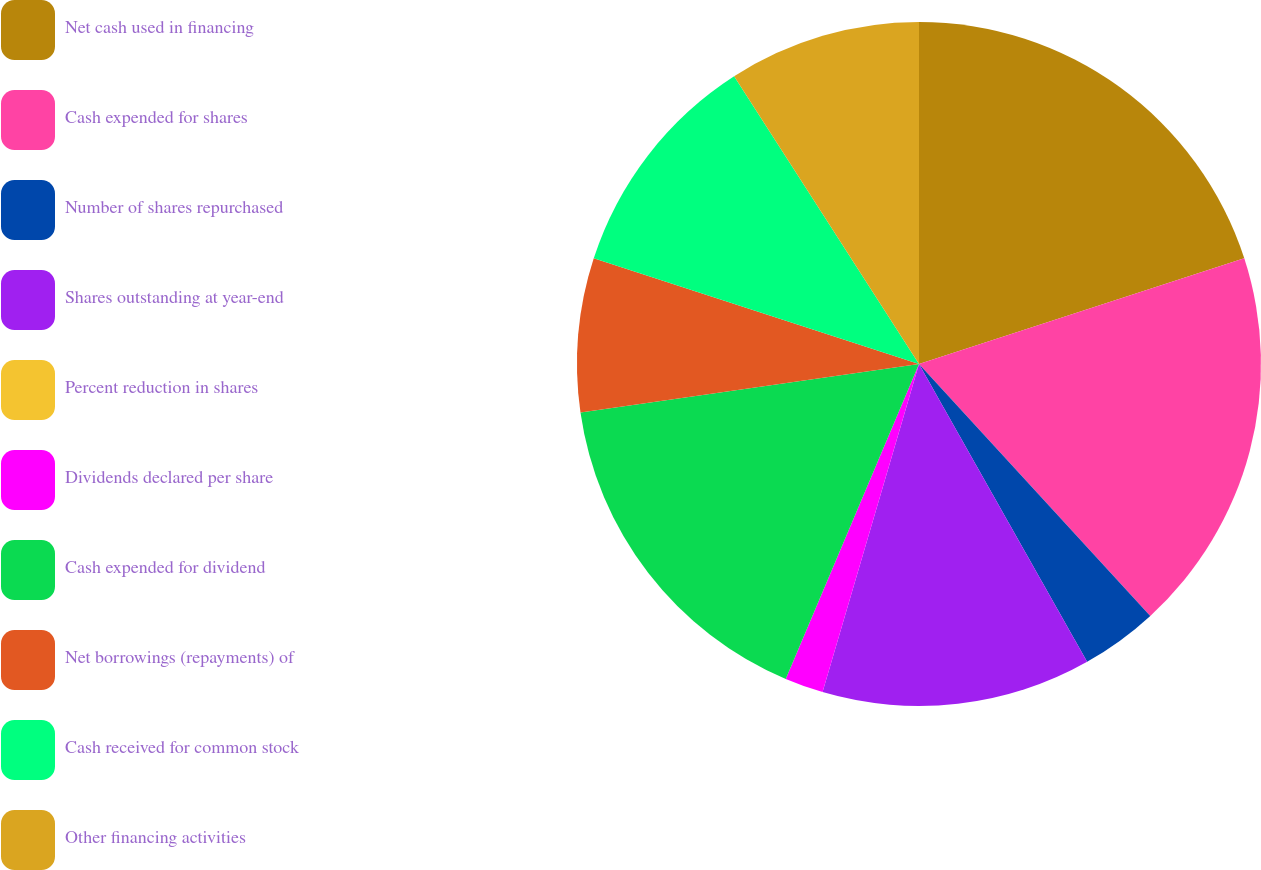Convert chart to OTSL. <chart><loc_0><loc_0><loc_500><loc_500><pie_chart><fcel>Net cash used in financing<fcel>Cash expended for shares<fcel>Number of shares repurchased<fcel>Shares outstanding at year-end<fcel>Percent reduction in shares<fcel>Dividends declared per share<fcel>Cash expended for dividend<fcel>Net borrowings (repayments) of<fcel>Cash received for common stock<fcel>Other financing activities<nl><fcel>20.0%<fcel>18.18%<fcel>3.64%<fcel>12.73%<fcel>0.0%<fcel>1.82%<fcel>16.36%<fcel>7.27%<fcel>10.91%<fcel>9.09%<nl></chart> 